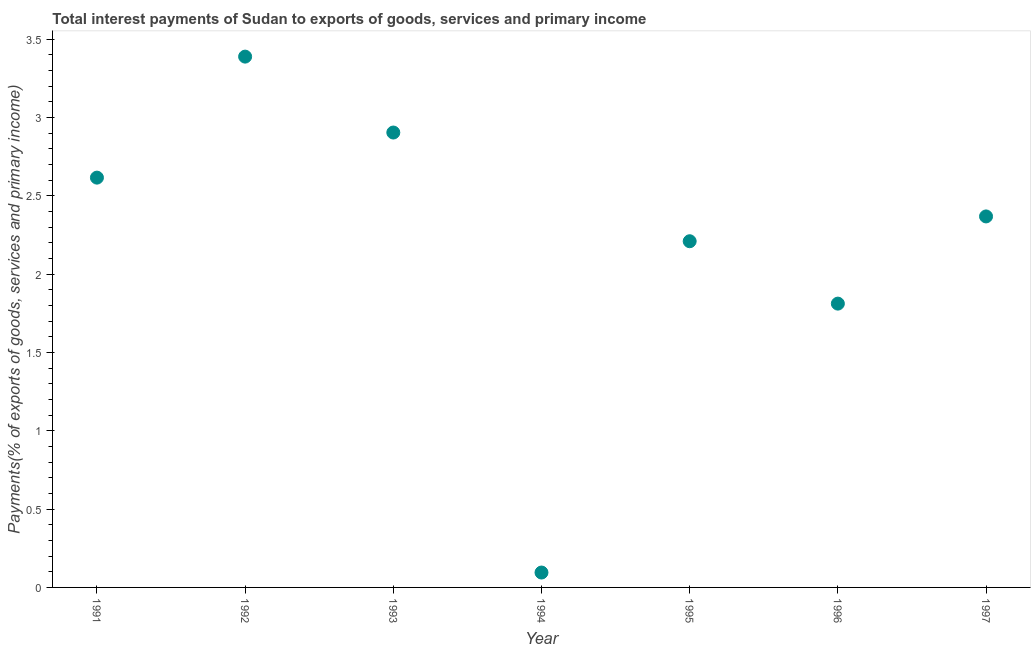What is the total interest payments on external debt in 1996?
Keep it short and to the point. 1.81. Across all years, what is the maximum total interest payments on external debt?
Ensure brevity in your answer.  3.39. Across all years, what is the minimum total interest payments on external debt?
Provide a succinct answer. 0.1. In which year was the total interest payments on external debt minimum?
Offer a very short reply. 1994. What is the sum of the total interest payments on external debt?
Provide a short and direct response. 15.39. What is the difference between the total interest payments on external debt in 1995 and 1996?
Your response must be concise. 0.4. What is the average total interest payments on external debt per year?
Ensure brevity in your answer.  2.2. What is the median total interest payments on external debt?
Provide a short and direct response. 2.37. What is the ratio of the total interest payments on external debt in 1992 to that in 1997?
Your answer should be compact. 1.43. Is the total interest payments on external debt in 1992 less than that in 1994?
Your answer should be compact. No. Is the difference between the total interest payments on external debt in 1992 and 1995 greater than the difference between any two years?
Provide a short and direct response. No. What is the difference between the highest and the second highest total interest payments on external debt?
Your response must be concise. 0.48. What is the difference between the highest and the lowest total interest payments on external debt?
Your answer should be very brief. 3.29. How many dotlines are there?
Your response must be concise. 1. How many years are there in the graph?
Offer a very short reply. 7. Are the values on the major ticks of Y-axis written in scientific E-notation?
Provide a succinct answer. No. Does the graph contain grids?
Keep it short and to the point. No. What is the title of the graph?
Make the answer very short. Total interest payments of Sudan to exports of goods, services and primary income. What is the label or title of the Y-axis?
Ensure brevity in your answer.  Payments(% of exports of goods, services and primary income). What is the Payments(% of exports of goods, services and primary income) in 1991?
Offer a very short reply. 2.62. What is the Payments(% of exports of goods, services and primary income) in 1992?
Ensure brevity in your answer.  3.39. What is the Payments(% of exports of goods, services and primary income) in 1993?
Provide a short and direct response. 2.9. What is the Payments(% of exports of goods, services and primary income) in 1994?
Offer a terse response. 0.1. What is the Payments(% of exports of goods, services and primary income) in 1995?
Provide a succinct answer. 2.21. What is the Payments(% of exports of goods, services and primary income) in 1996?
Provide a succinct answer. 1.81. What is the Payments(% of exports of goods, services and primary income) in 1997?
Provide a succinct answer. 2.37. What is the difference between the Payments(% of exports of goods, services and primary income) in 1991 and 1992?
Ensure brevity in your answer.  -0.77. What is the difference between the Payments(% of exports of goods, services and primary income) in 1991 and 1993?
Your response must be concise. -0.29. What is the difference between the Payments(% of exports of goods, services and primary income) in 1991 and 1994?
Ensure brevity in your answer.  2.52. What is the difference between the Payments(% of exports of goods, services and primary income) in 1991 and 1995?
Your answer should be very brief. 0.41. What is the difference between the Payments(% of exports of goods, services and primary income) in 1991 and 1996?
Keep it short and to the point. 0.8. What is the difference between the Payments(% of exports of goods, services and primary income) in 1991 and 1997?
Keep it short and to the point. 0.25. What is the difference between the Payments(% of exports of goods, services and primary income) in 1992 and 1993?
Ensure brevity in your answer.  0.48. What is the difference between the Payments(% of exports of goods, services and primary income) in 1992 and 1994?
Ensure brevity in your answer.  3.29. What is the difference between the Payments(% of exports of goods, services and primary income) in 1992 and 1995?
Your answer should be compact. 1.18. What is the difference between the Payments(% of exports of goods, services and primary income) in 1992 and 1996?
Keep it short and to the point. 1.58. What is the difference between the Payments(% of exports of goods, services and primary income) in 1992 and 1997?
Make the answer very short. 1.02. What is the difference between the Payments(% of exports of goods, services and primary income) in 1993 and 1994?
Make the answer very short. 2.81. What is the difference between the Payments(% of exports of goods, services and primary income) in 1993 and 1995?
Provide a short and direct response. 0.69. What is the difference between the Payments(% of exports of goods, services and primary income) in 1993 and 1996?
Keep it short and to the point. 1.09. What is the difference between the Payments(% of exports of goods, services and primary income) in 1993 and 1997?
Offer a very short reply. 0.54. What is the difference between the Payments(% of exports of goods, services and primary income) in 1994 and 1995?
Give a very brief answer. -2.12. What is the difference between the Payments(% of exports of goods, services and primary income) in 1994 and 1996?
Your answer should be very brief. -1.72. What is the difference between the Payments(% of exports of goods, services and primary income) in 1994 and 1997?
Your answer should be very brief. -2.27. What is the difference between the Payments(% of exports of goods, services and primary income) in 1995 and 1996?
Ensure brevity in your answer.  0.4. What is the difference between the Payments(% of exports of goods, services and primary income) in 1995 and 1997?
Ensure brevity in your answer.  -0.16. What is the difference between the Payments(% of exports of goods, services and primary income) in 1996 and 1997?
Give a very brief answer. -0.56. What is the ratio of the Payments(% of exports of goods, services and primary income) in 1991 to that in 1992?
Keep it short and to the point. 0.77. What is the ratio of the Payments(% of exports of goods, services and primary income) in 1991 to that in 1993?
Make the answer very short. 0.9. What is the ratio of the Payments(% of exports of goods, services and primary income) in 1991 to that in 1994?
Your answer should be compact. 27.52. What is the ratio of the Payments(% of exports of goods, services and primary income) in 1991 to that in 1995?
Your answer should be very brief. 1.18. What is the ratio of the Payments(% of exports of goods, services and primary income) in 1991 to that in 1996?
Make the answer very short. 1.44. What is the ratio of the Payments(% of exports of goods, services and primary income) in 1991 to that in 1997?
Make the answer very short. 1.1. What is the ratio of the Payments(% of exports of goods, services and primary income) in 1992 to that in 1993?
Offer a very short reply. 1.17. What is the ratio of the Payments(% of exports of goods, services and primary income) in 1992 to that in 1994?
Your answer should be very brief. 35.65. What is the ratio of the Payments(% of exports of goods, services and primary income) in 1992 to that in 1995?
Offer a terse response. 1.53. What is the ratio of the Payments(% of exports of goods, services and primary income) in 1992 to that in 1996?
Keep it short and to the point. 1.87. What is the ratio of the Payments(% of exports of goods, services and primary income) in 1992 to that in 1997?
Give a very brief answer. 1.43. What is the ratio of the Payments(% of exports of goods, services and primary income) in 1993 to that in 1994?
Make the answer very short. 30.55. What is the ratio of the Payments(% of exports of goods, services and primary income) in 1993 to that in 1995?
Keep it short and to the point. 1.31. What is the ratio of the Payments(% of exports of goods, services and primary income) in 1993 to that in 1996?
Your answer should be very brief. 1.6. What is the ratio of the Payments(% of exports of goods, services and primary income) in 1993 to that in 1997?
Give a very brief answer. 1.23. What is the ratio of the Payments(% of exports of goods, services and primary income) in 1994 to that in 1995?
Provide a succinct answer. 0.04. What is the ratio of the Payments(% of exports of goods, services and primary income) in 1994 to that in 1996?
Your response must be concise. 0.05. What is the ratio of the Payments(% of exports of goods, services and primary income) in 1995 to that in 1996?
Give a very brief answer. 1.22. What is the ratio of the Payments(% of exports of goods, services and primary income) in 1995 to that in 1997?
Your response must be concise. 0.93. What is the ratio of the Payments(% of exports of goods, services and primary income) in 1996 to that in 1997?
Your answer should be very brief. 0.77. 